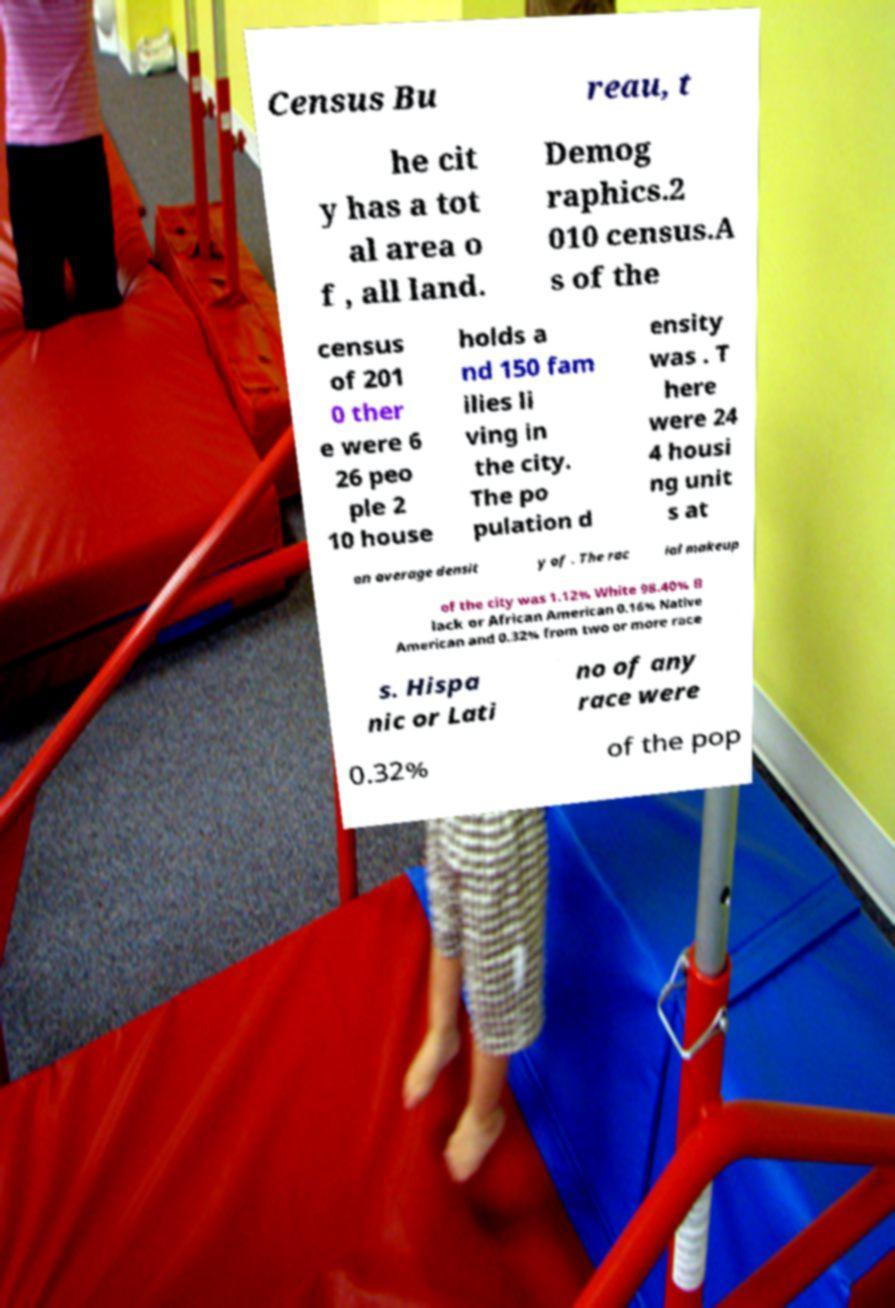Please identify and transcribe the text found in this image. Census Bu reau, t he cit y has a tot al area o f , all land. Demog raphics.2 010 census.A s of the census of 201 0 ther e were 6 26 peo ple 2 10 house holds a nd 150 fam ilies li ving in the city. The po pulation d ensity was . T here were 24 4 housi ng unit s at an average densit y of . The rac ial makeup of the city was 1.12% White 98.40% B lack or African American 0.16% Native American and 0.32% from two or more race s. Hispa nic or Lati no of any race were 0.32% of the pop 